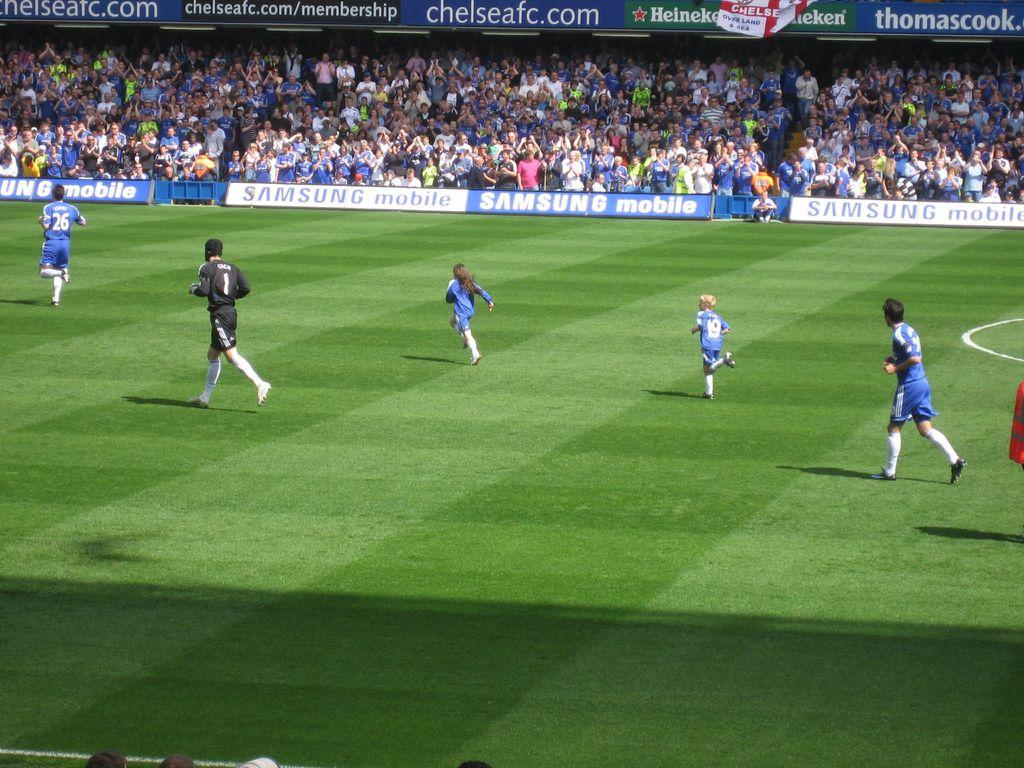What are the people in the image doing? The people in the image are players, and they are running on a playground. Can you describe the setting of the image? The players are running on a playground, and there are spectators in the background. What type of collar is the dog wearing in the image? There is no dog or collar present in the image; it features players running on a playground with spectators in the background. 